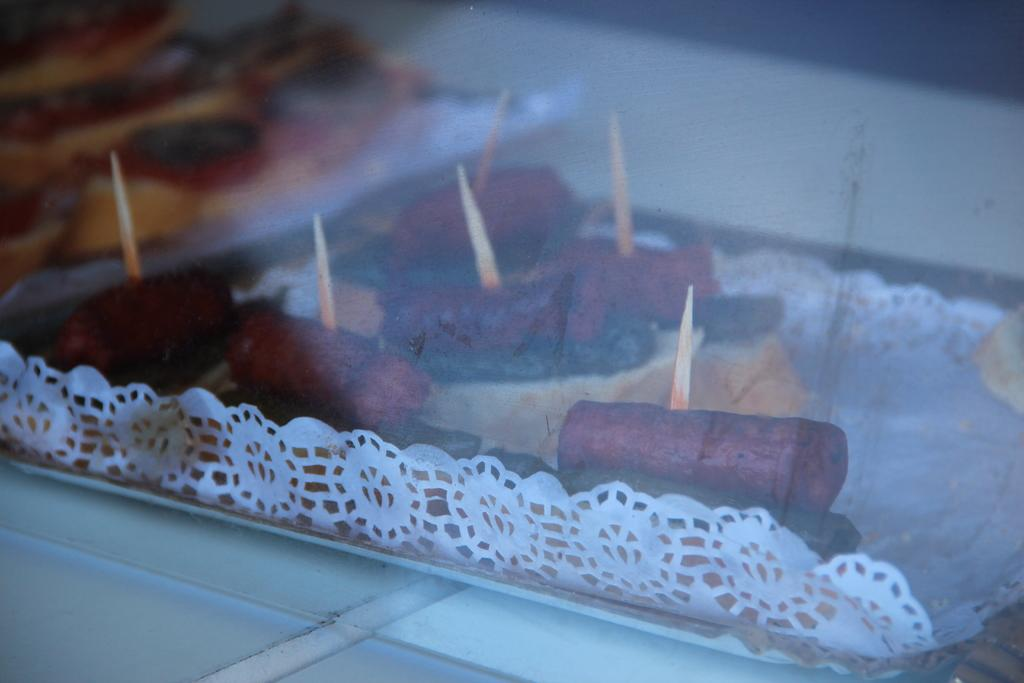What type of container is visible in the image? There is a transparent glass in the image. What is inside the glass? There are no items inside the glass, but there are food items on a paper behind the glass. How would you describe the appearance of the food items' background? The background behind the food items is blurred. What type of room is depicted in the image? There is no room visible in the image; it only shows a transparent glass and food items on a paper. What type of competition is taking place in the image? There is no competition present in the image. 